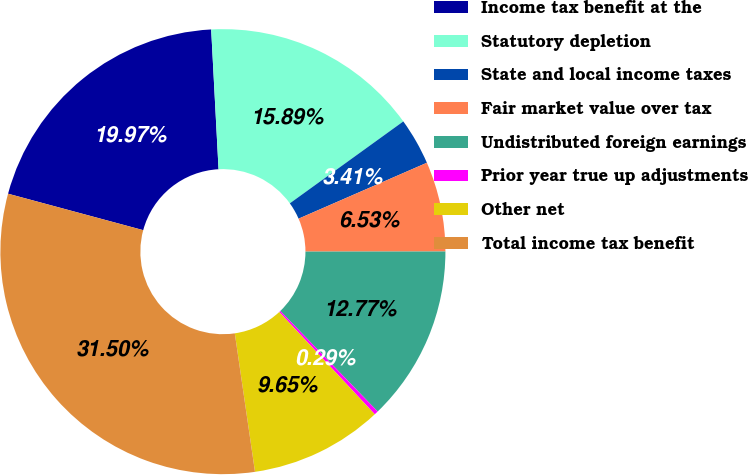Convert chart to OTSL. <chart><loc_0><loc_0><loc_500><loc_500><pie_chart><fcel>Income tax benefit at the<fcel>Statutory depletion<fcel>State and local income taxes<fcel>Fair market value over tax<fcel>Undistributed foreign earnings<fcel>Prior year true up adjustments<fcel>Other net<fcel>Total income tax benefit<nl><fcel>19.97%<fcel>15.89%<fcel>3.41%<fcel>6.53%<fcel>12.77%<fcel>0.29%<fcel>9.65%<fcel>31.5%<nl></chart> 